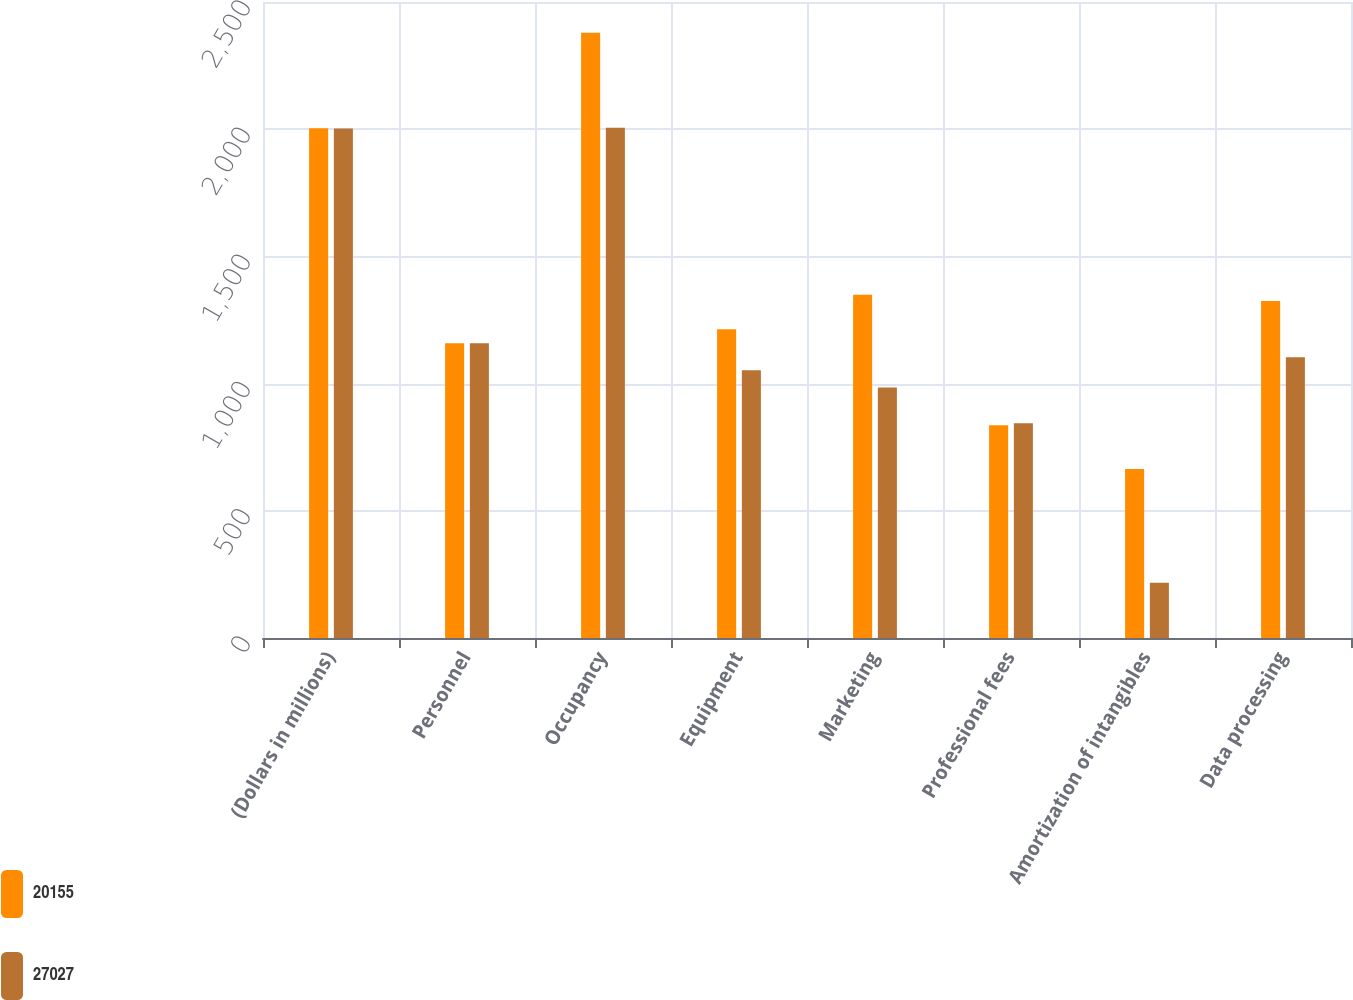Convert chart to OTSL. <chart><loc_0><loc_0><loc_500><loc_500><stacked_bar_chart><ecel><fcel>(Dollars in millions)<fcel>Personnel<fcel>Occupancy<fcel>Equipment<fcel>Marketing<fcel>Professional fees<fcel>Amortization of intangibles<fcel>Data processing<nl><fcel>20155<fcel>2004<fcel>1159<fcel>2379<fcel>1214<fcel>1349<fcel>836<fcel>664<fcel>1325<nl><fcel>27027<fcel>2003<fcel>1159<fcel>2006<fcel>1052<fcel>985<fcel>844<fcel>217<fcel>1104<nl></chart> 